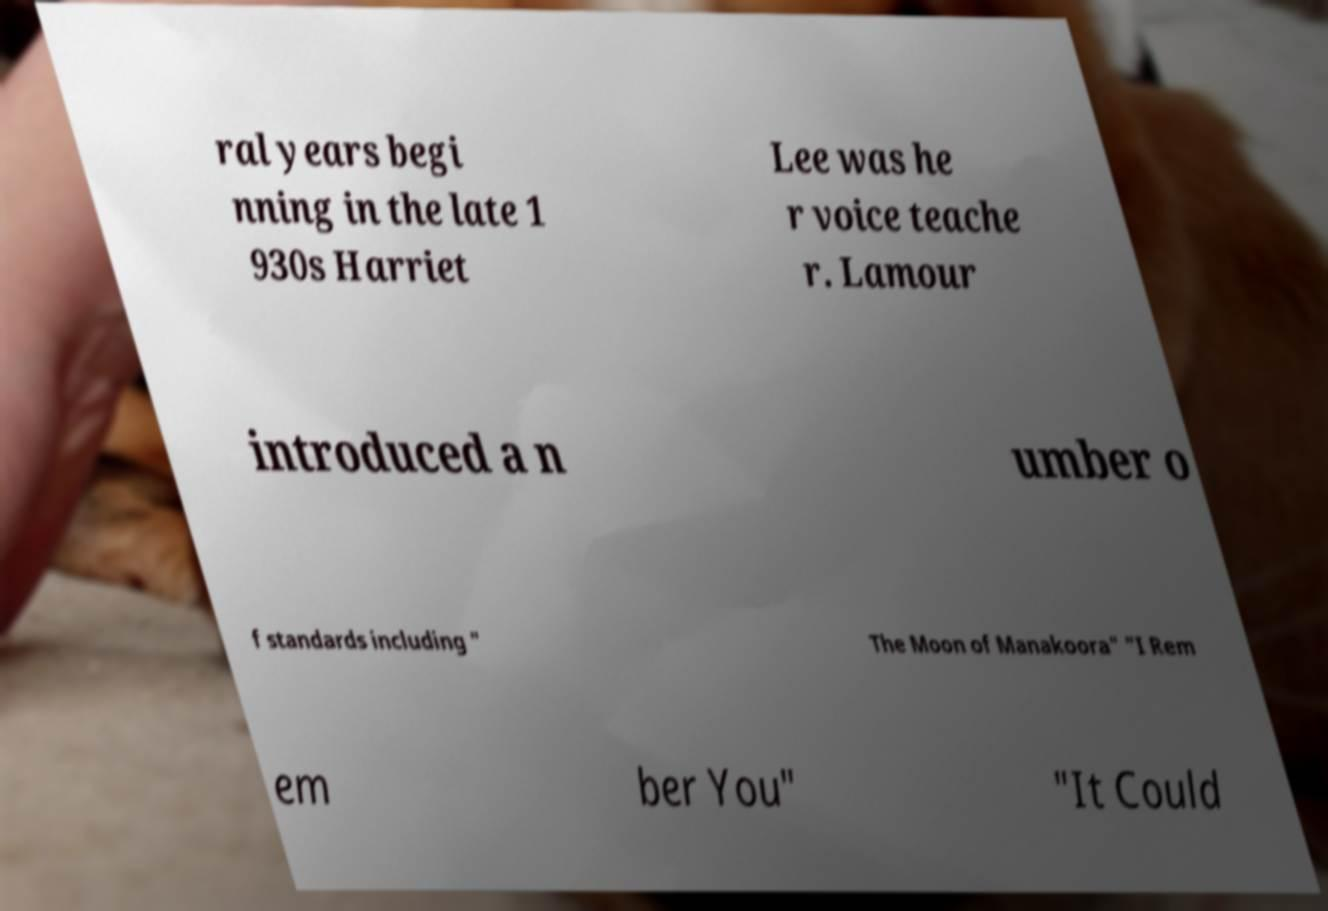I need the written content from this picture converted into text. Can you do that? ral years begi nning in the late 1 930s Harriet Lee was he r voice teache r. Lamour introduced a n umber o f standards including " The Moon of Manakoora" "I Rem em ber You" "It Could 